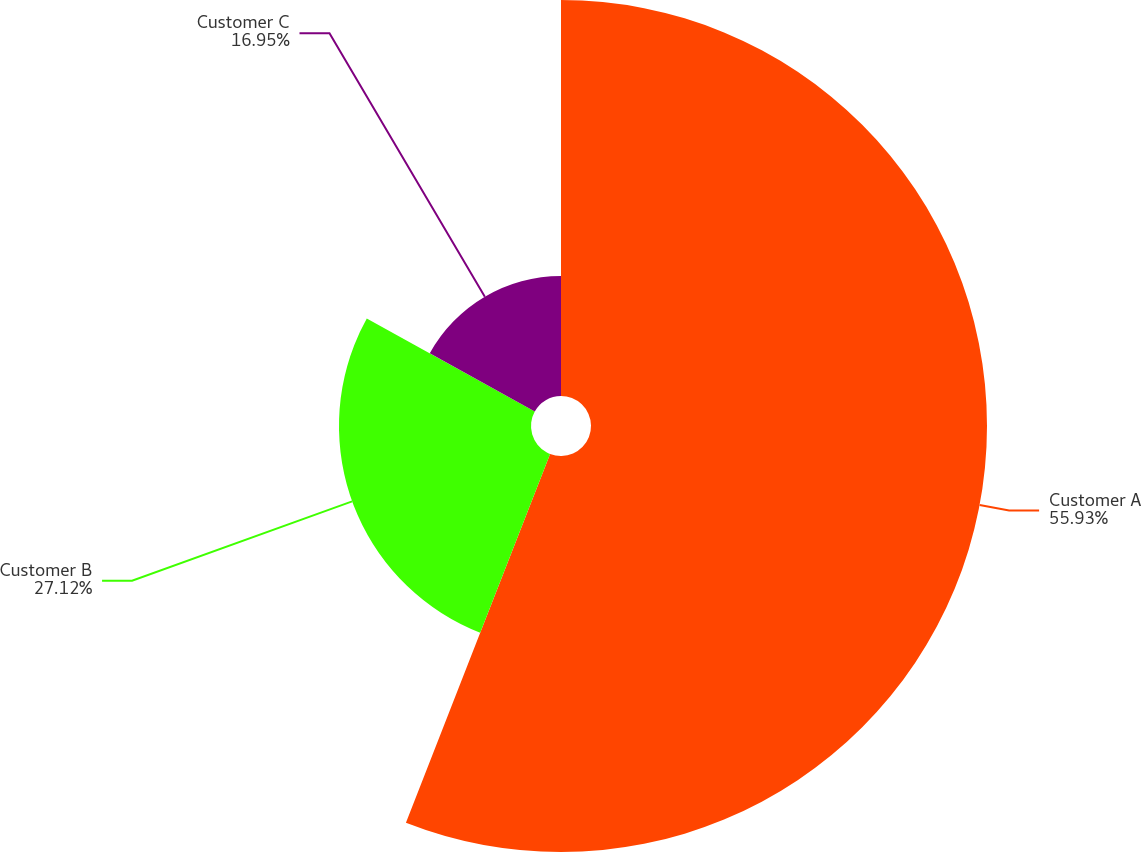<chart> <loc_0><loc_0><loc_500><loc_500><pie_chart><fcel>Customer A<fcel>Customer B<fcel>Customer C<nl><fcel>55.93%<fcel>27.12%<fcel>16.95%<nl></chart> 